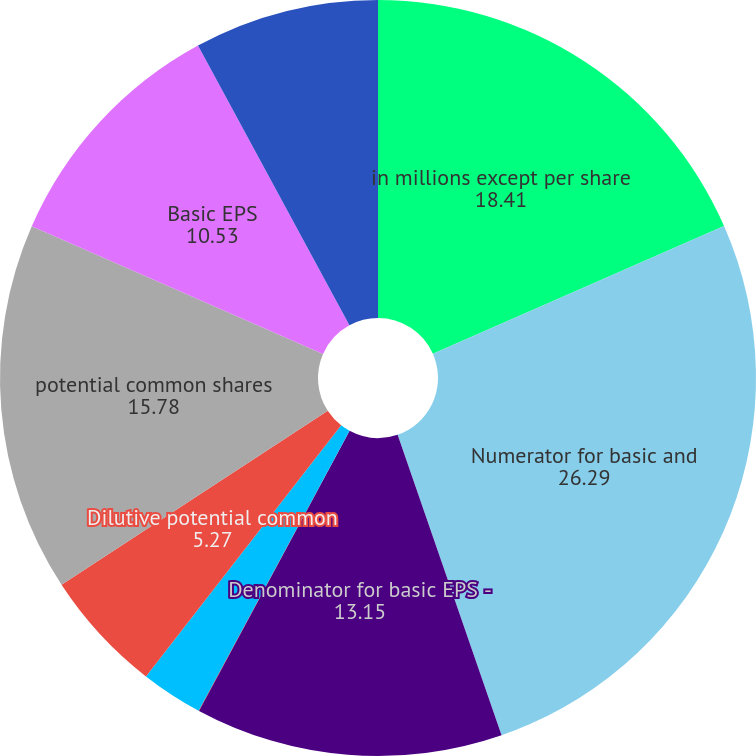Convert chart. <chart><loc_0><loc_0><loc_500><loc_500><pie_chart><fcel>in millions except per share<fcel>Numerator for basic and<fcel>Denominator for basic EPS -<fcel>Effect of dilutive securities<fcel>Stock options and warrants<fcel>Dilutive potential common<fcel>potential common shares<fcel>Basic EPS<fcel>Diluted EPS<nl><fcel>18.41%<fcel>26.29%<fcel>13.15%<fcel>0.02%<fcel>2.65%<fcel>5.27%<fcel>15.78%<fcel>10.53%<fcel>7.9%<nl></chart> 